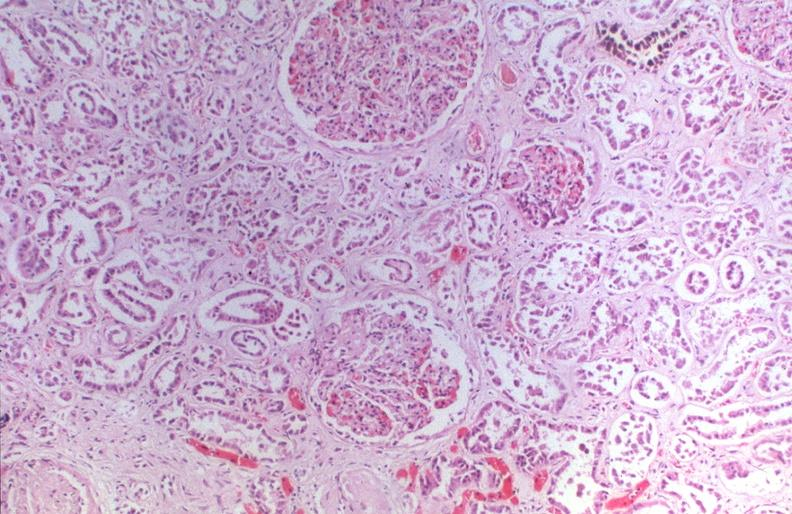what does this image show?
Answer the question using a single word or phrase. Kidney 